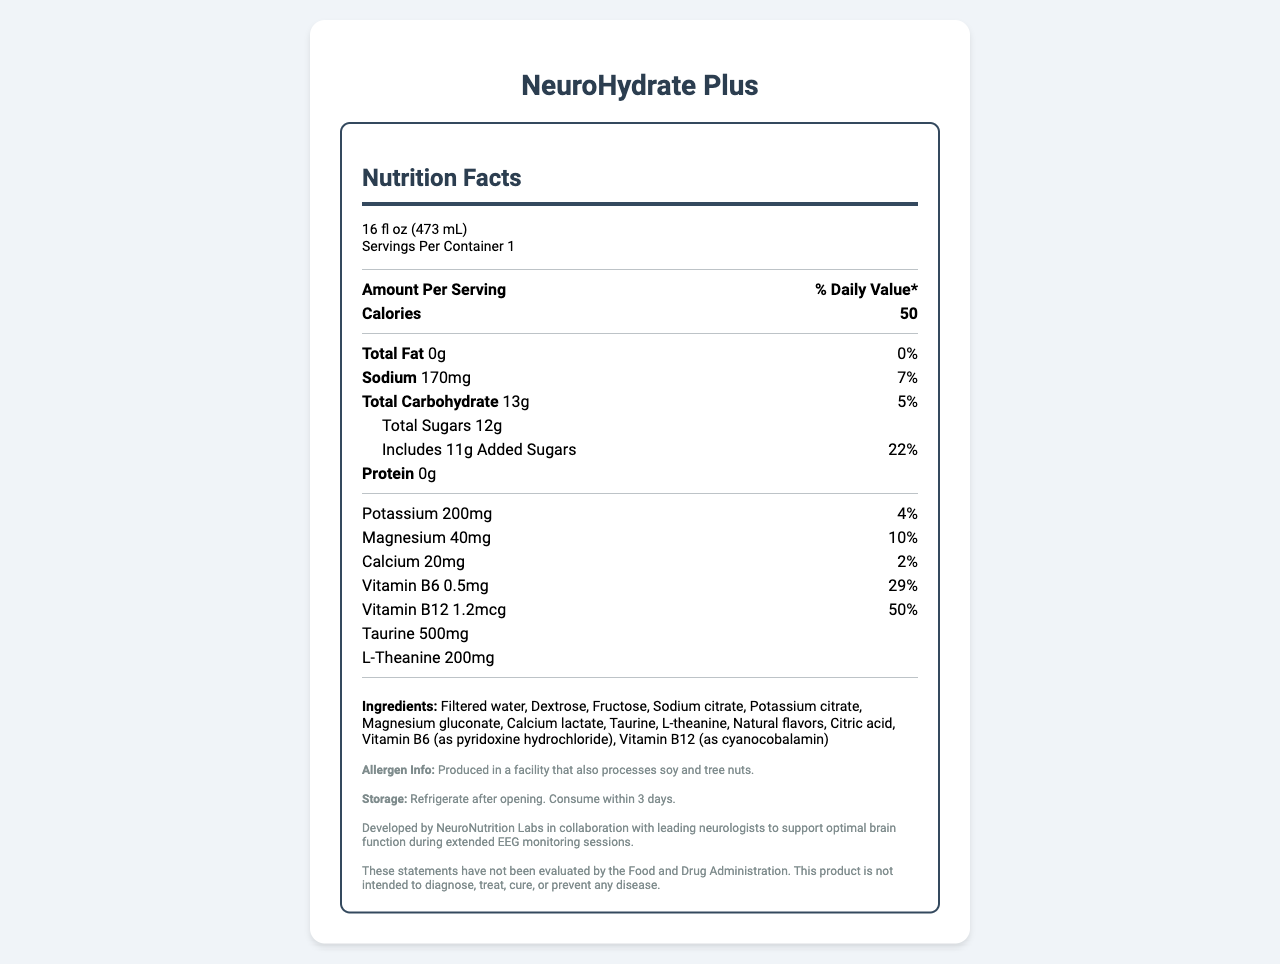what is the serving size of NeuroHydrate Plus? The serving size is explicitly stated under the 'Nutrition Facts' heading as "16 fl oz (473 mL)".
Answer: 16 fl oz (473 mL) how many calories are in one serving of NeuroHydrate Plus? The number of calories is listed directly under the 'Amount Per Serving' section as 50.
Answer: 50 what is the percentage of daily value for sodium in NeuroHydrate Plus? The percentage of daily value for sodium is provided right next to the sodium amount (170mg) as 7%.
Answer: 7% what ingredients in NeuroHydrate Plus support neural function? The ingredients that specifically support neural function are listed as Taurine (500mg) and L-Theanine (200mg) under the 'Nutrition Facts' section.
Answer: Taurine and L-Theanine how much Vitamin B12 is in one serving of NeuroHydrate Plus? The amount of Vitamin B12 is listed in the 'Nutrition Facts' section as 1.2mcg.
Answer: 1.2mcg which of the following nutrients is included in the highest quantity in NeuroHydrate Plus? A. Sodium B. Potassium C. Magnesium The amounts listed are Sodium (170mg), Potassium (200mg), and Magnesium (40mg). Sodium has the highest quantity at 170mg.
Answer: A. Sodium what is the daily value percentage for Vitamin B6 in NeuroHydrate Plus? A. 22% B. 74% C. 29% The daily value percentage for Vitamin B6 is provided in the 'Nutrition Facts' section as 29%.
Answer: C. 29% is NeuroHydrate Plus suitable for people with soy allergies? The allergen information states that it is produced in a facility that also processes soy and tree nuts, making it potentially unsuitable for people with soy allergies.
Answer: No can the product be stored at room temperature after opening? The storage instructions specify that the product should be refrigerated after opening and consumed within 3 days.
Answer: No summarize the main features of NeuroHydrate Plus. The explanation provides an overview of the key components, purpose, nutrient content, collaborative development, and usage instructions based on the information available in the document.
Answer: NeuroHydrate Plus is an electrolyte-balanced beverage designed to support proper neural function during prolonged EEG monitoring sessions. It contains essential nutrients like sodium, potassium, magnesium, calcium, and vitamins B6 and B12. The beverage is enriched with taurine and L-theanine. Designed collaboratively with leading neurologists, it aims to support brain function but has not been FDA-evaluated for treating or preventing diseases. It must be refrigerated after opening. who is the target audience for NeuroHydrate Plus? The document mentions that it was developed to support neural function during EEG monitoring sessions but does not specify the exact target audience.
Answer: Not enough information 